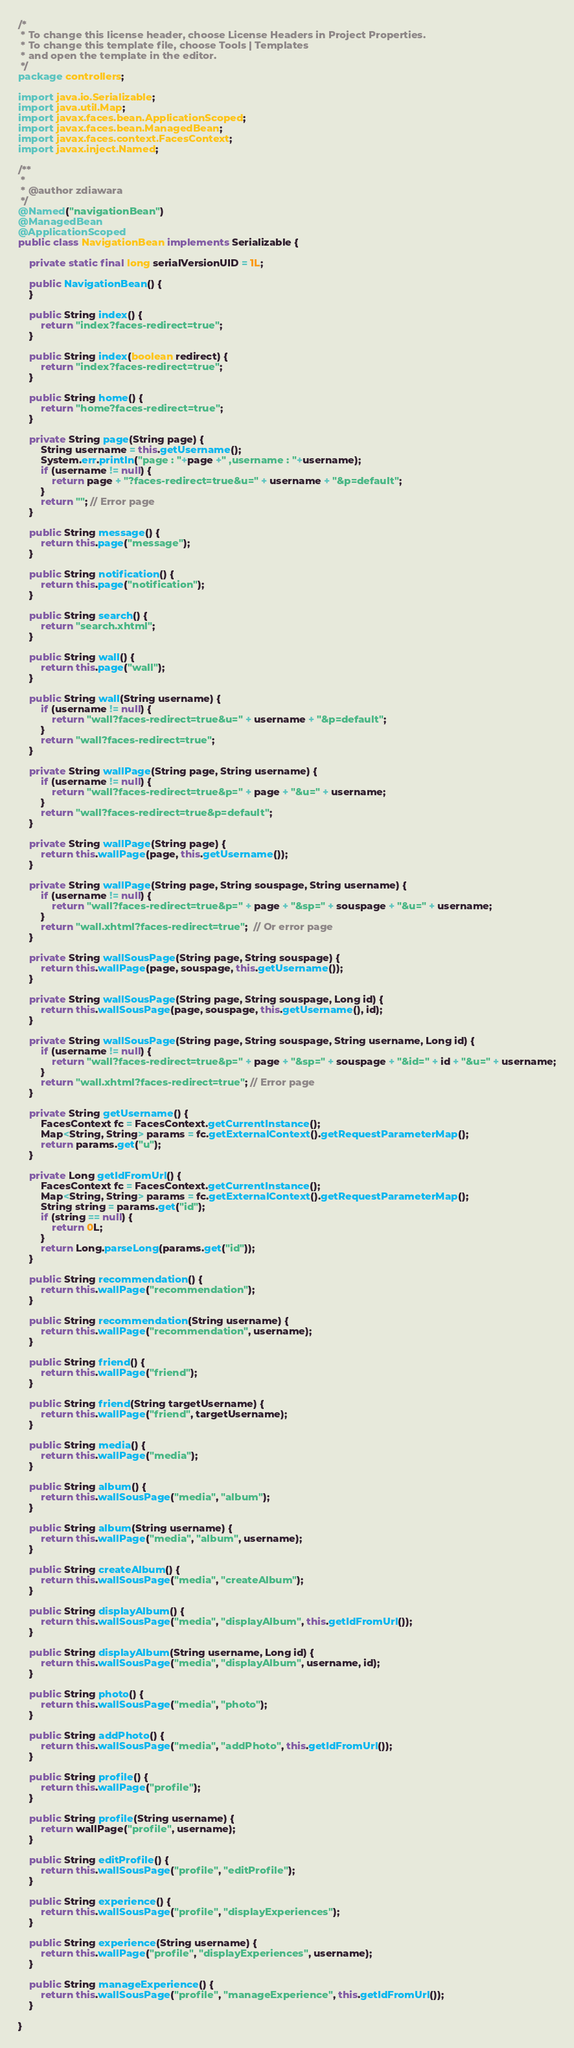<code> <loc_0><loc_0><loc_500><loc_500><_Java_>/*
 * To change this license header, choose License Headers in Project Properties.
 * To change this template file, choose Tools | Templates
 * and open the template in the editor.
 */
package controllers;

import java.io.Serializable;
import java.util.Map;
import javax.faces.bean.ApplicationScoped;
import javax.faces.bean.ManagedBean;
import javax.faces.context.FacesContext;
import javax.inject.Named;

/**
 *
 * @author zdiawara
 */
@Named("navigationBean")
@ManagedBean
@ApplicationScoped
public class NavigationBean implements Serializable {

    private static final long serialVersionUID = 1L;

    public NavigationBean() {
    }

    public String index() {
        return "index?faces-redirect=true";      
    }

    public String index(boolean redirect) {
        return "index?faces-redirect=true";
    }

    public String home() {
        return "home?faces-redirect=true";
    }

    private String page(String page) {
        String username = this.getUsername();
        System.err.println("page : "+page +" ,username : "+username);
        if (username != null) {
            return page + "?faces-redirect=true&u=" + username + "&p=default";
        }
        return ""; // Error page
    }

    public String message() {
        return this.page("message");
    }

    public String notification() {
        return this.page("notification");
    }

    public String search() {
        return "search.xhtml";
    }

    public String wall() {
        return this.page("wall");
    }

    public String wall(String username) {
        if (username != null) {
            return "wall?faces-redirect=true&u=" + username + "&p=default";
        }
        return "wall?faces-redirect=true";
    }

    private String wallPage(String page, String username) {
        if (username != null) {
            return "wall?faces-redirect=true&p=" + page + "&u=" + username;
        }
        return "wall?faces-redirect=true&p=default";
    }

    private String wallPage(String page) {
        return this.wallPage(page, this.getUsername());
    }

    private String wallPage(String page, String souspage, String username) {
        if (username != null) {
            return "wall?faces-redirect=true&p=" + page + "&sp=" + souspage + "&u=" + username;
        }
        return "wall.xhtml?faces-redirect=true";  // Or error page 
    }

    private String wallSousPage(String page, String souspage) {
        return this.wallPage(page, souspage, this.getUsername());
    }

    private String wallSousPage(String page, String souspage, Long id) {
        return this.wallSousPage(page, souspage, this.getUsername(), id);
    }

    private String wallSousPage(String page, String souspage, String username, Long id) {
        if (username != null) {
            return "wall?faces-redirect=true&p=" + page + "&sp=" + souspage + "&id=" + id + "&u=" + username;
        }
        return "wall.xhtml?faces-redirect=true"; // Error page 
    }

    private String getUsername() {
        FacesContext fc = FacesContext.getCurrentInstance();
        Map<String, String> params = fc.getExternalContext().getRequestParameterMap();
        return params.get("u");
    }

    private Long getIdFromUrl() {
        FacesContext fc = FacesContext.getCurrentInstance();
        Map<String, String> params = fc.getExternalContext().getRequestParameterMap();
        String string = params.get("id");
        if (string == null) {
            return 0L;
        }
        return Long.parseLong(params.get("id"));
    }

    public String recommendation() {
        return this.wallPage("recommendation");
    }

    public String recommendation(String username) {
        return this.wallPage("recommendation", username);
    }

    public String friend() {
        return this.wallPage("friend");
    }

    public String friend(String targetUsername) {
        return this.wallPage("friend", targetUsername);
    }

    public String media() {
        return this.wallPage("media");
    }

    public String album() {
        return this.wallSousPage("media", "album");
    }

    public String album(String username) {
        return this.wallPage("media", "album", username);
    }

    public String createAlbum() {
        return this.wallSousPage("media", "createAlbum");
    }

    public String displayAlbum() {
        return this.wallSousPage("media", "displayAlbum", this.getIdFromUrl());
    }

    public String displayAlbum(String username, Long id) {
        return this.wallSousPage("media", "displayAlbum", username, id);
    }

    public String photo() {
        return this.wallSousPage("media", "photo");
    }

    public String addPhoto() {
        return this.wallSousPage("media", "addPhoto", this.getIdFromUrl());
    }

    public String profile() {
        return this.wallPage("profile");
    }

    public String profile(String username) {
        return wallPage("profile", username);
    }

    public String editProfile() {
        return this.wallSousPage("profile", "editProfile");
    }

    public String experience() {
        return this.wallSousPage("profile", "displayExperiences");
    }

    public String experience(String username) {
        return this.wallPage("profile", "displayExperiences", username);
    }

    public String manageExperience() {
        return this.wallSousPage("profile", "manageExperience", this.getIdFromUrl());
    }

}
</code> 